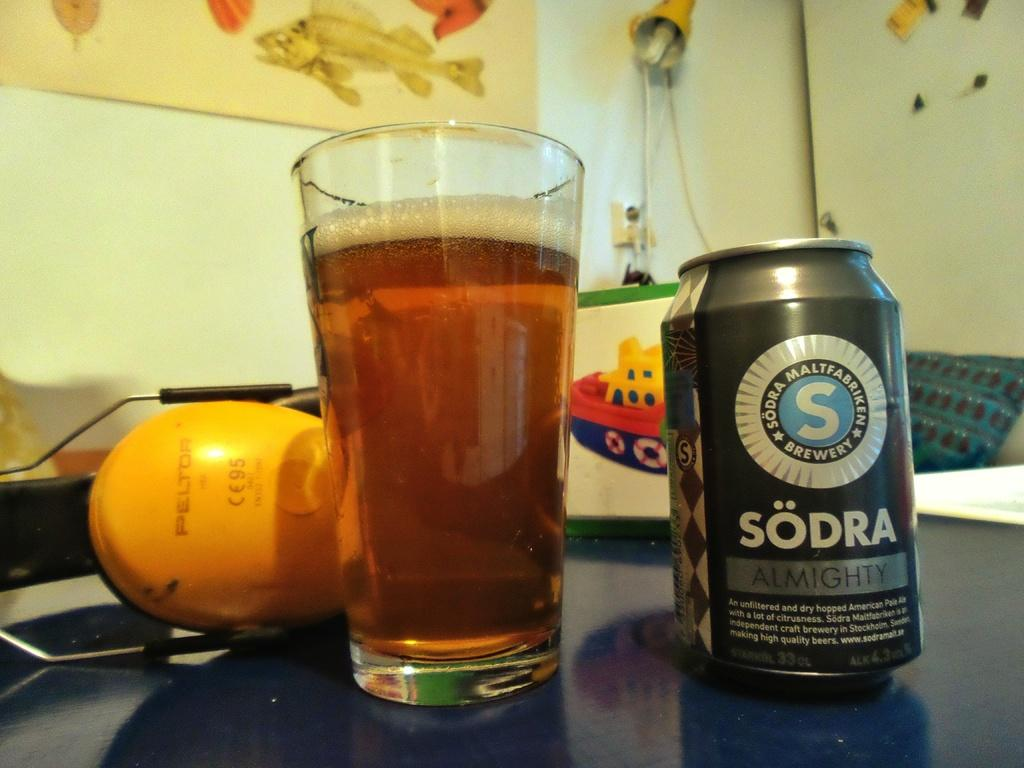<image>
Offer a succinct explanation of the picture presented. A grey Sodra almighty beer can next to a full glass of beer on a table. 